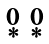Convert formula to latex. <formula><loc_0><loc_0><loc_500><loc_500>\begin{smallmatrix} 0 & 0 \\ * & * \end{smallmatrix}</formula> 